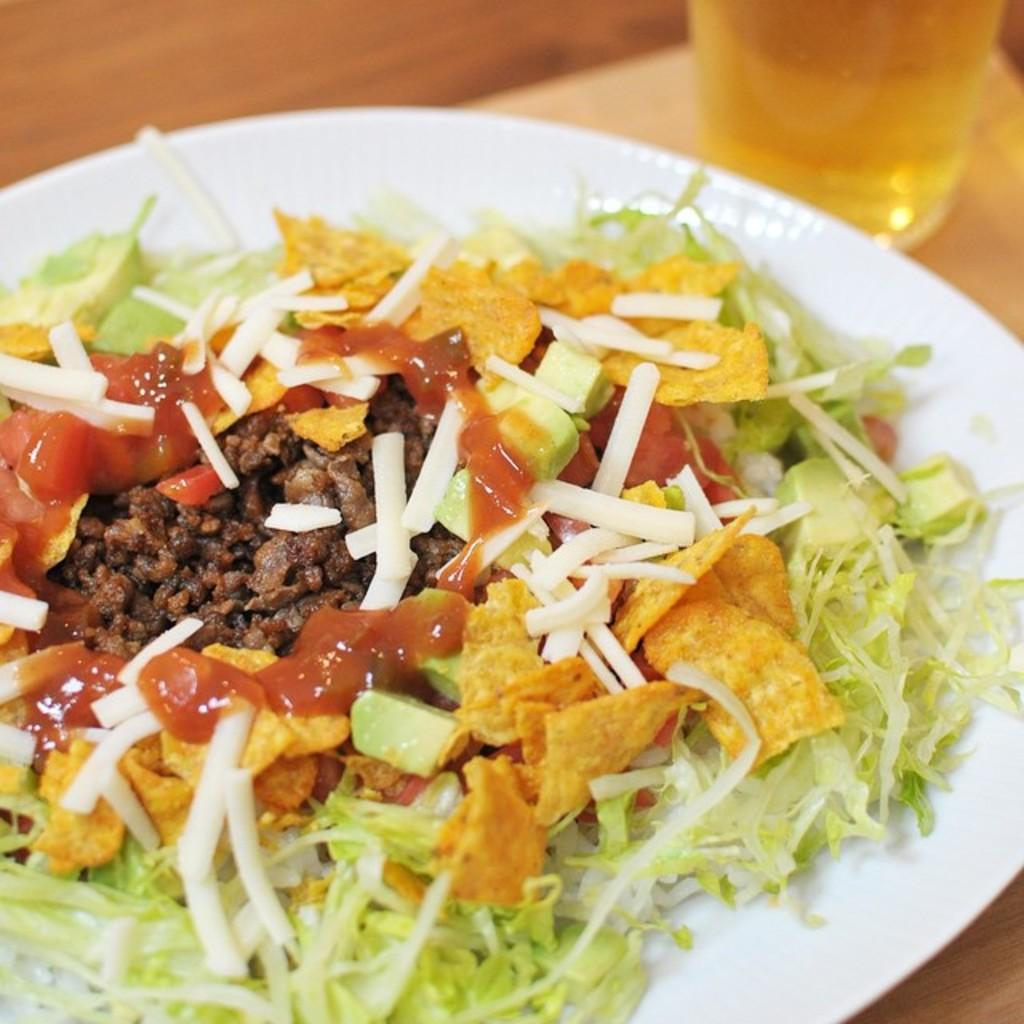What is the main object in the center of the image? There is a table in the center of the image. What is placed on the table? There is a plate on the table, and the plate contains a food item. What else is on the table? There is a glass on the table, and the glass contains a liquid. What type of calculator is being used during the protest in the image? There is no calculator or protest present in the image; it features a table with a plate and a glass. 